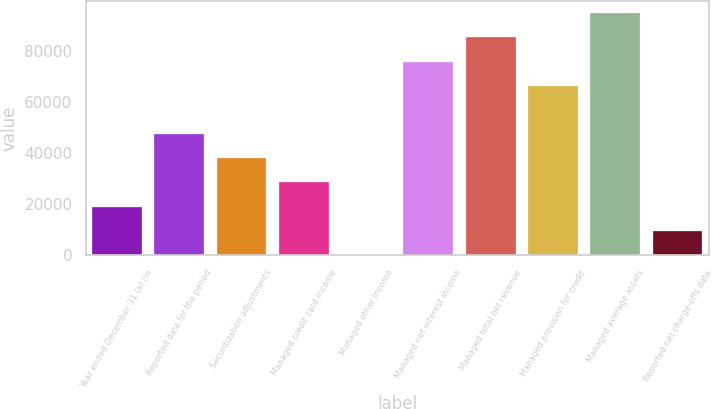Convert chart. <chart><loc_0><loc_0><loc_500><loc_500><bar_chart><fcel>Year ended December 31 (a) (in<fcel>Reported data for the period<fcel>Securitization adjustments<fcel>Managed credit card income<fcel>Managed other income<fcel>Managed net interest income<fcel>Managed total net revenue<fcel>Managed provision for credit<fcel>Managed average assets<fcel>Reported net charge-offs data<nl><fcel>19041.8<fcel>47429<fcel>37966.6<fcel>28504.2<fcel>117<fcel>75816.2<fcel>85278.6<fcel>66353.8<fcel>94741<fcel>9579.4<nl></chart> 